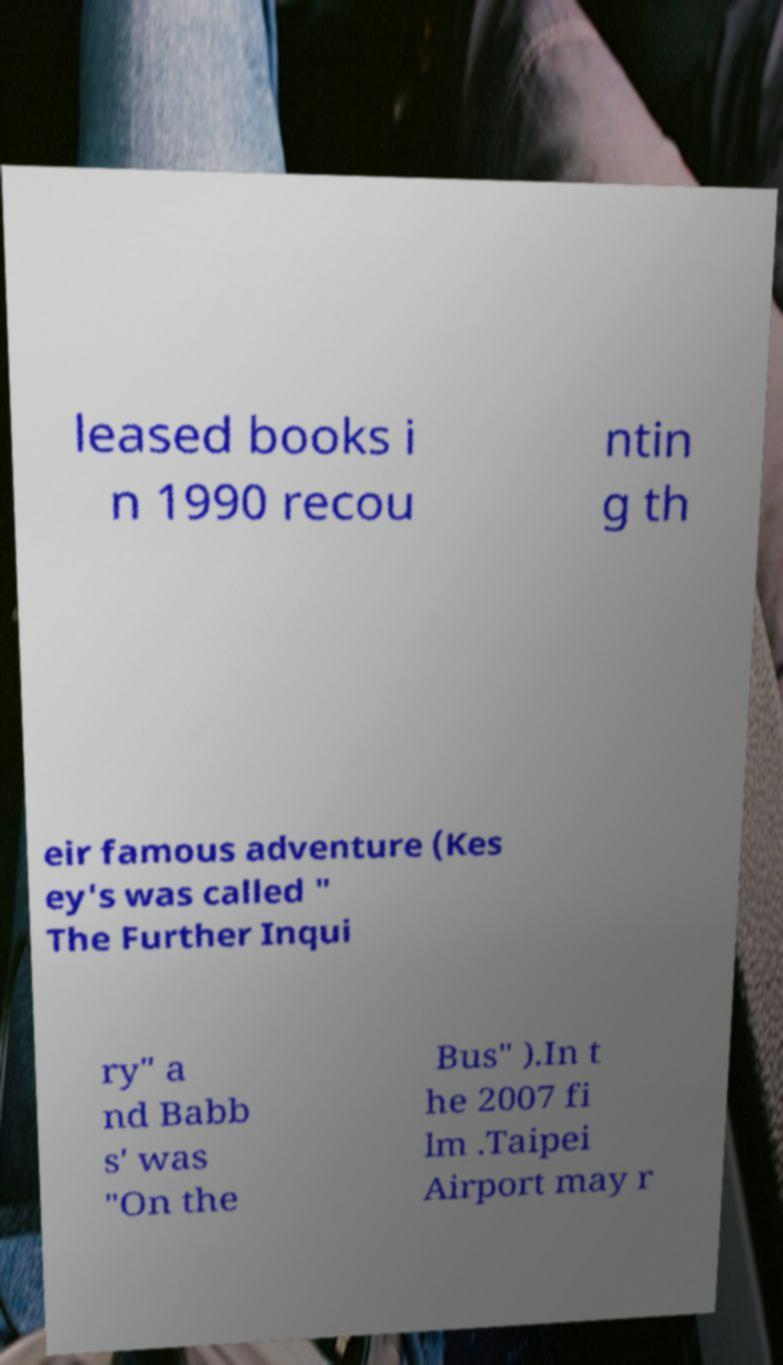Can you accurately transcribe the text from the provided image for me? leased books i n 1990 recou ntin g th eir famous adventure (Kes ey's was called " The Further Inqui ry" a nd Babb s' was "On the Bus" ).In t he 2007 fi lm .Taipei Airport may r 